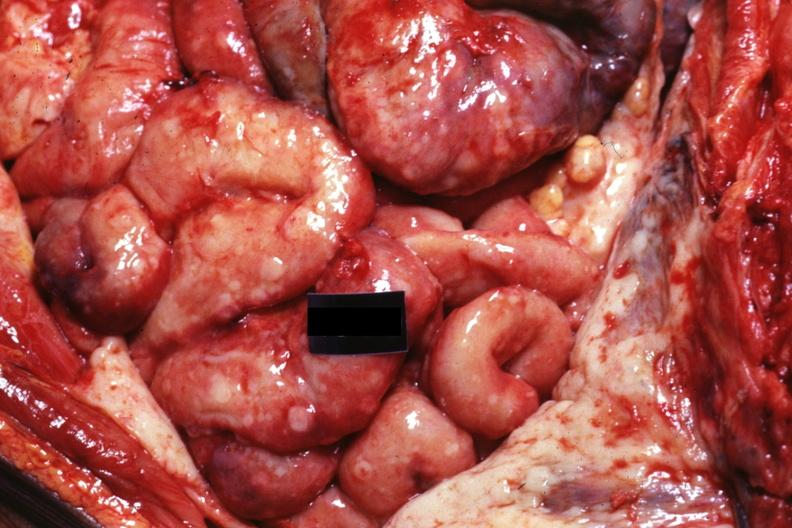what is present?
Answer the question using a single word or phrase. Carcinomatosis 